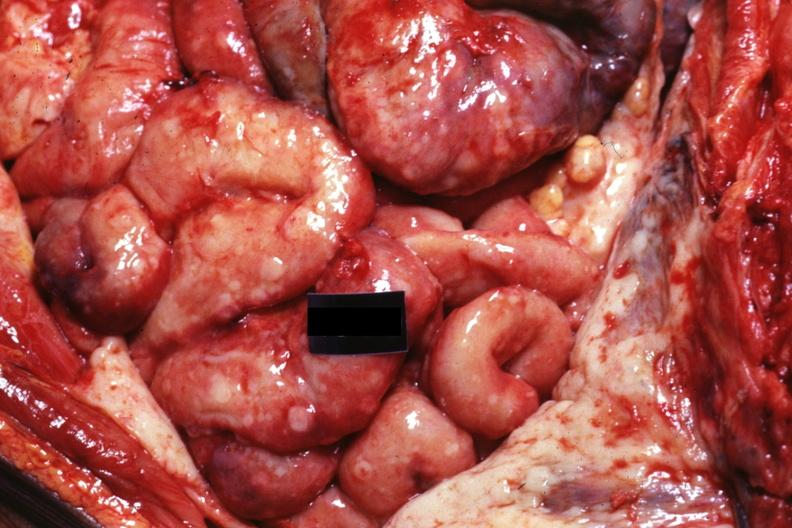what is present?
Answer the question using a single word or phrase. Carcinomatosis 